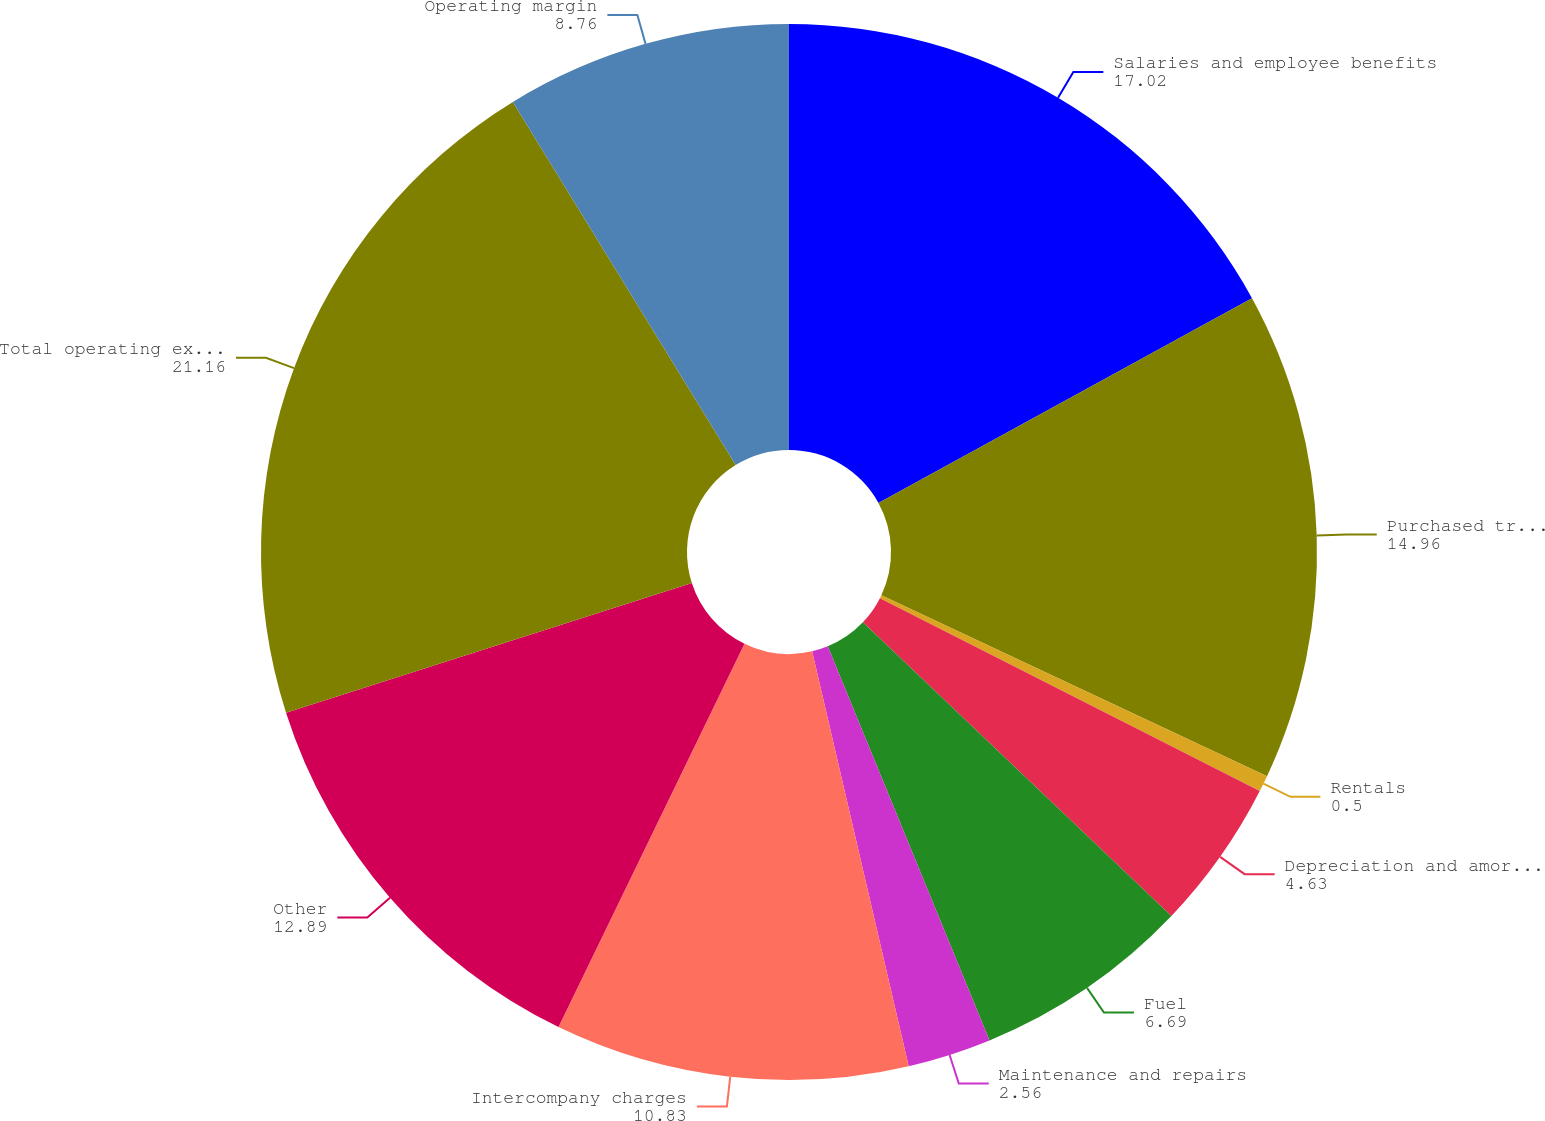Convert chart. <chart><loc_0><loc_0><loc_500><loc_500><pie_chart><fcel>Salaries and employee benefits<fcel>Purchased transportation<fcel>Rentals<fcel>Depreciation and amortization<fcel>Fuel<fcel>Maintenance and repairs<fcel>Intercompany charges<fcel>Other<fcel>Total operating expenses<fcel>Operating margin<nl><fcel>17.02%<fcel>14.96%<fcel>0.5%<fcel>4.63%<fcel>6.69%<fcel>2.56%<fcel>10.83%<fcel>12.89%<fcel>21.16%<fcel>8.76%<nl></chart> 